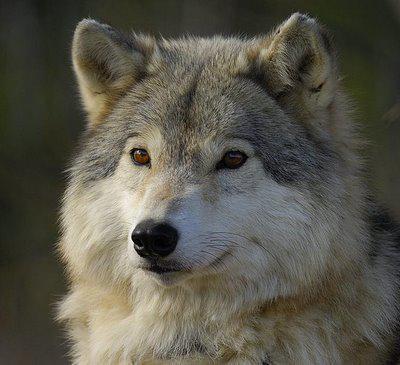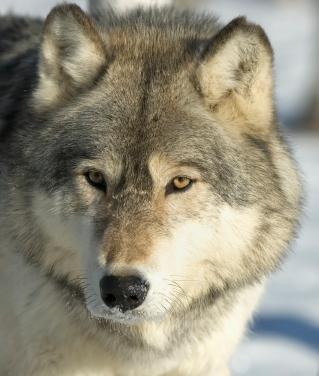The first image is the image on the left, the second image is the image on the right. Examine the images to the left and right. Is the description "Multiple wolves are depicted in the left image." accurate? Answer yes or no. No. 